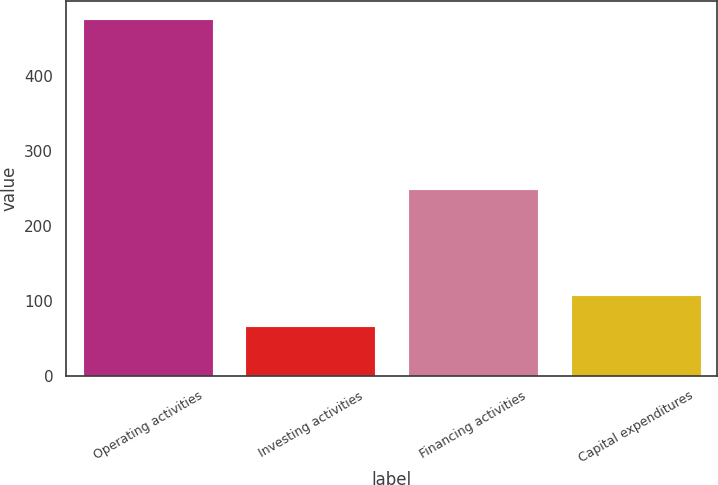<chart> <loc_0><loc_0><loc_500><loc_500><bar_chart><fcel>Operating activities<fcel>Investing activities<fcel>Financing activities<fcel>Capital expenditures<nl><fcel>476<fcel>67<fcel>249<fcel>107.9<nl></chart> 